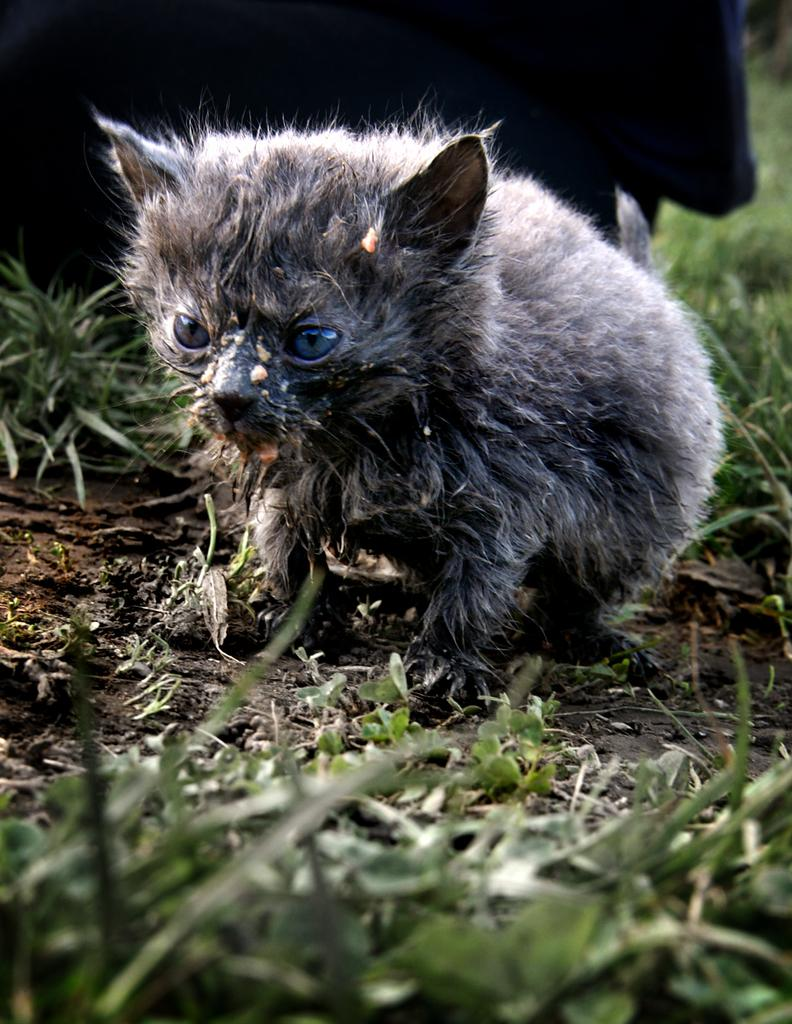What type of creature is in the image? There is an animal in the image. What color is the animal? The animal is in black and white color. What type of vegetation is visible in the image? There is green grass visible in the image. What type of terrain is visible in the image? There is mud visible in the image. What type of building can be seen in the background of the image? There is no building present in the image; it features an animal in black and white color with green grass and mud visible. What type of drink is the animal holding in the image? The animal is not holding any drink in the image. 